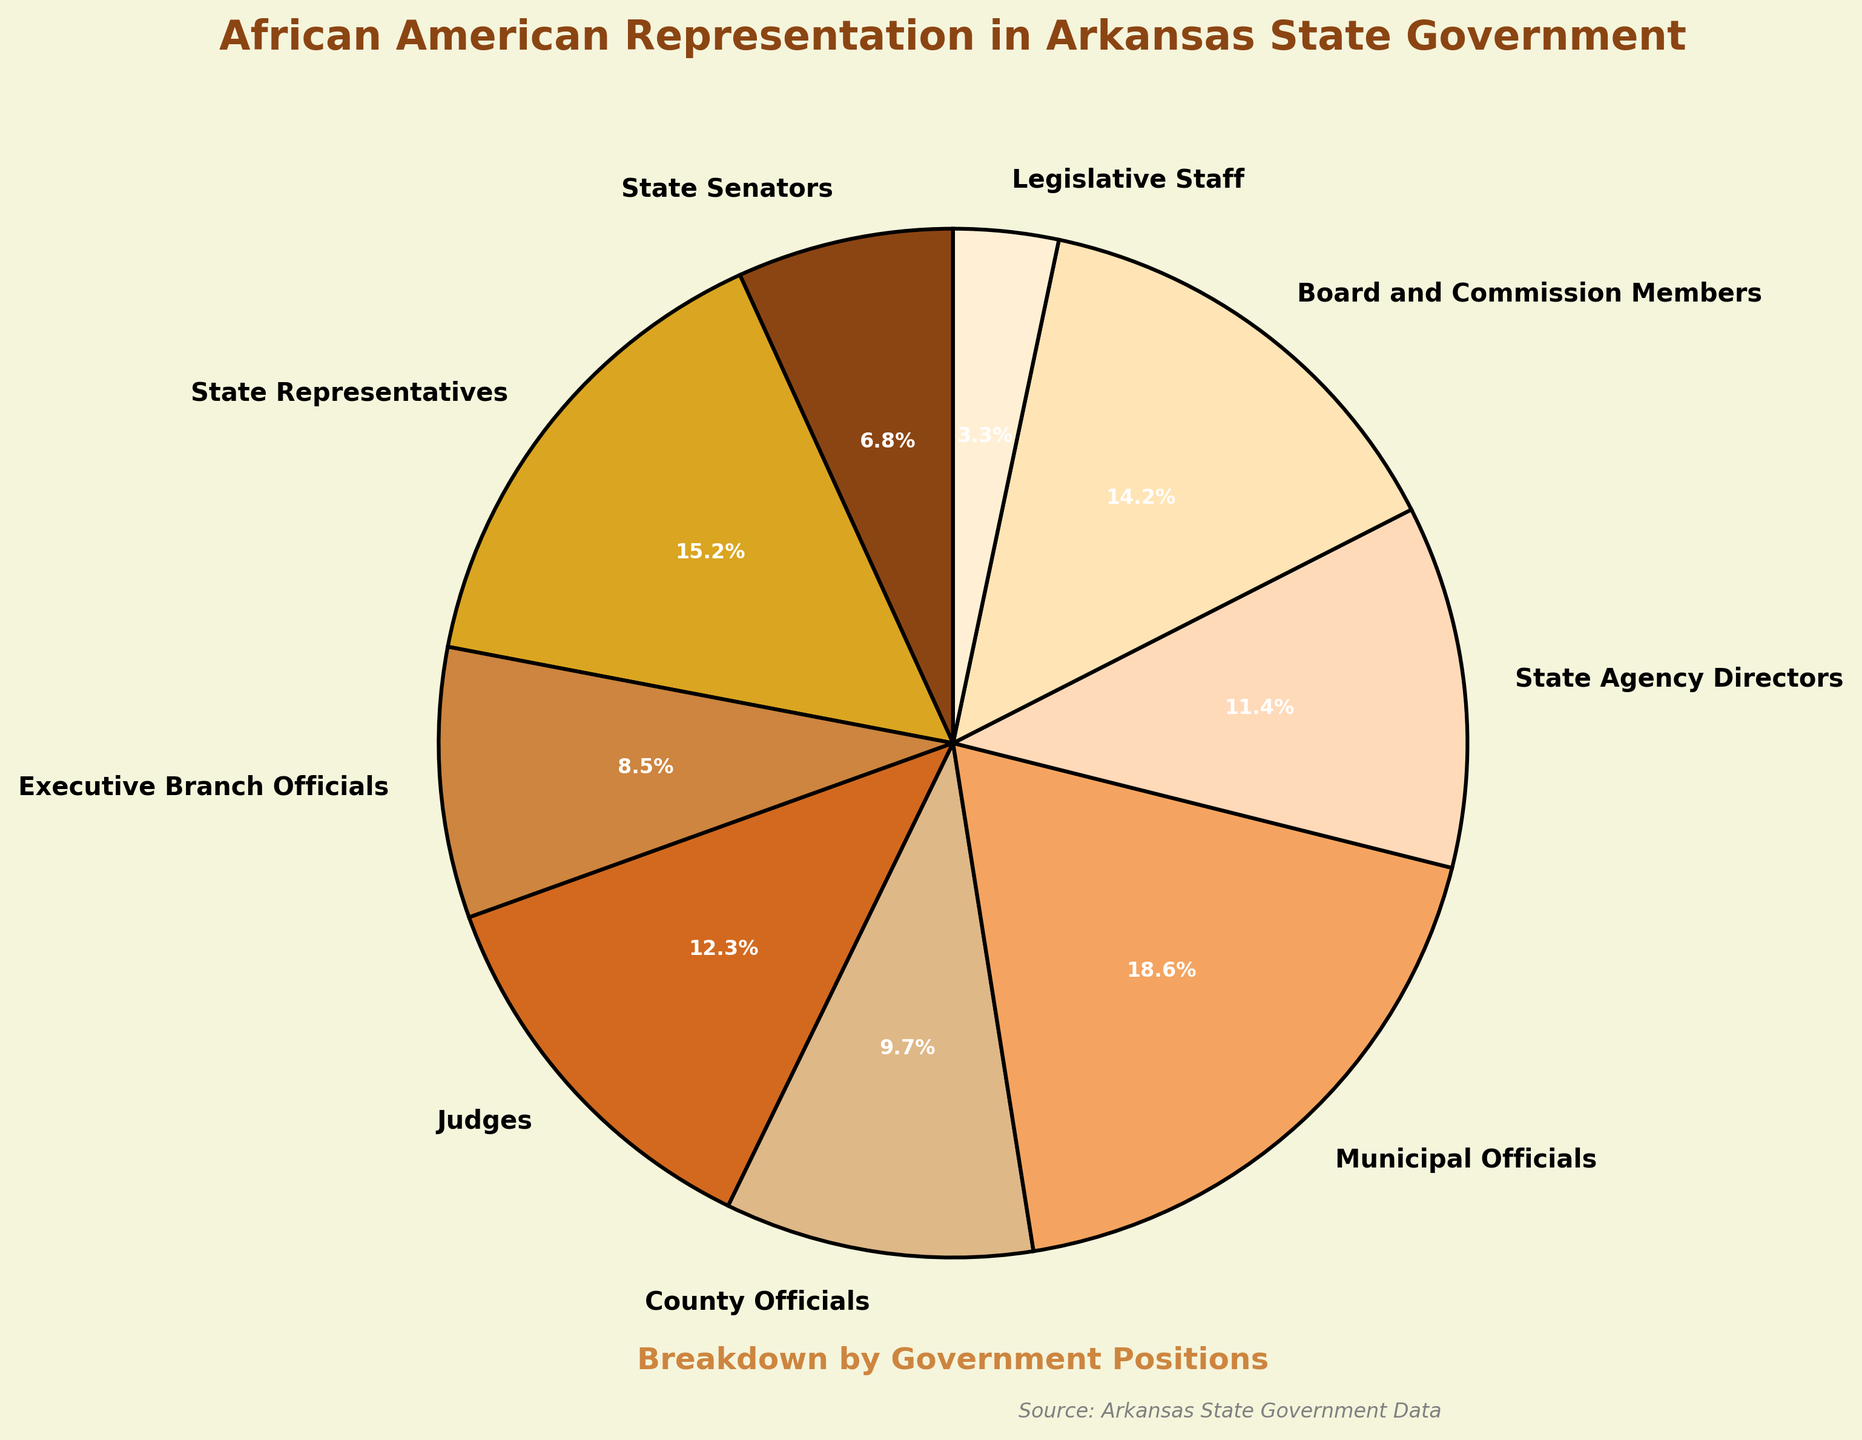What is the percentage of African Americans in the State Senators position? Look at the pie chart and find the label corresponding to 'State Senators'. The percentage next to it is 6.8%.
Answer: 6.8% Which position has the highest representation of African Americans? Examine the percentages next to each position label on the pie chart, and identify the highest one which is 'Municipal Officials' at 18.6%.
Answer: Municipal Officials How do the percentages of African Americans in the Executive Branch Officials and Judges positions compare? Refer to the pie chart to find the percentages for 'Executive Branch Officials' (8.5%) and 'Judges' (12.3%). Since 12.3% is greater than 8.5%, African Americans have a higher representation among Judges than Executive Branch Officials.
Answer: Judges have a higher representation What is the combined percentage of African American State Senators and State Representatives? Sum the percentages for 'State Senators' (6.8%) and 'State Representatives' (15.2%) from the pie chart. 6.8 + 15.2 = 22.0%.
Answer: 22.0% Which position has the lowest representation of African Americans? Identify the smallest percentage among all the positions from the pie chart, which is 'Legislative Staff' at 3.3%.
Answer: Legislative Staff Are African Americans more represented in Judges or County Officials positions? Compare the percentages for 'Judges' (12.3%) and 'County Officials' (9.7%) as shown in the pie chart. African Americans are more represented as Judges.
Answer: Judges How much more represented are African Americans in State Representatives compared to Legislative Staff? Subtract the percentage of 'Legislative Staff' (3.3%) from 'State Representatives' (15.2%). 15.2 - 3.3 = 11.9%.
Answer: 11.9% What proportion of the pie chart is occupied by roles within the legislative branch (State Senators, State Representatives, and Legislative Staff)? Add the percentages for 'State Senators' (6.8%), 'State Representatives' (15.2%), and 'Legislative Staff' (3.3%) from the pie chart. 6.8 + 15.2 + 3.3 = 25.3%.
Answer: 25.3% How does the percentage of African Americans in Board and Commission Members compare to that in State Agency Directors? Compare the percentages listed for 'Board and Commission Members' (14.2%) and 'State Agency Directors' (11.4%). African Americans have a higher representation among Board and Commission Members.
Answer: Board and Commission Members What is the total percentage representation of African Americans in all the positions listed in the pie chart? Sum all the given percentages: 6.8 + 15.2 + 8.5 + 12.3 + 9.7 + 18.6 + 11.4 + 14.2 + 3.3 = 100.0%.
Answer: 100.0% 